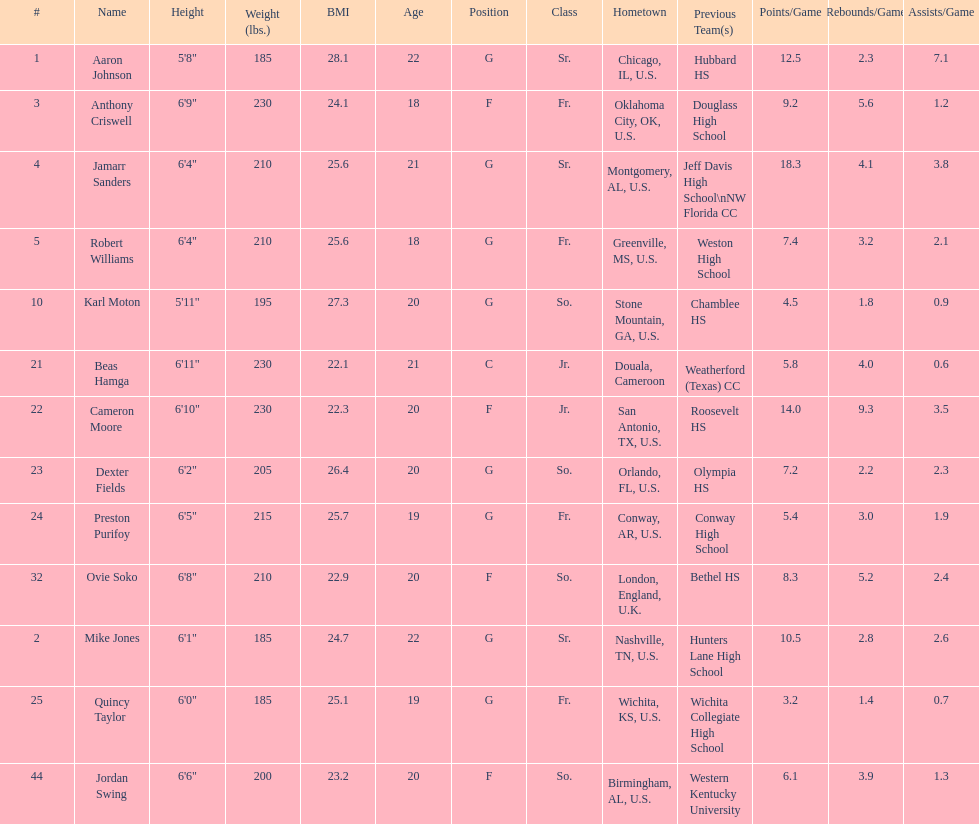How many total forwards are on the team? 4. 